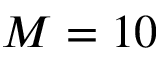<formula> <loc_0><loc_0><loc_500><loc_500>M = 1 0</formula> 